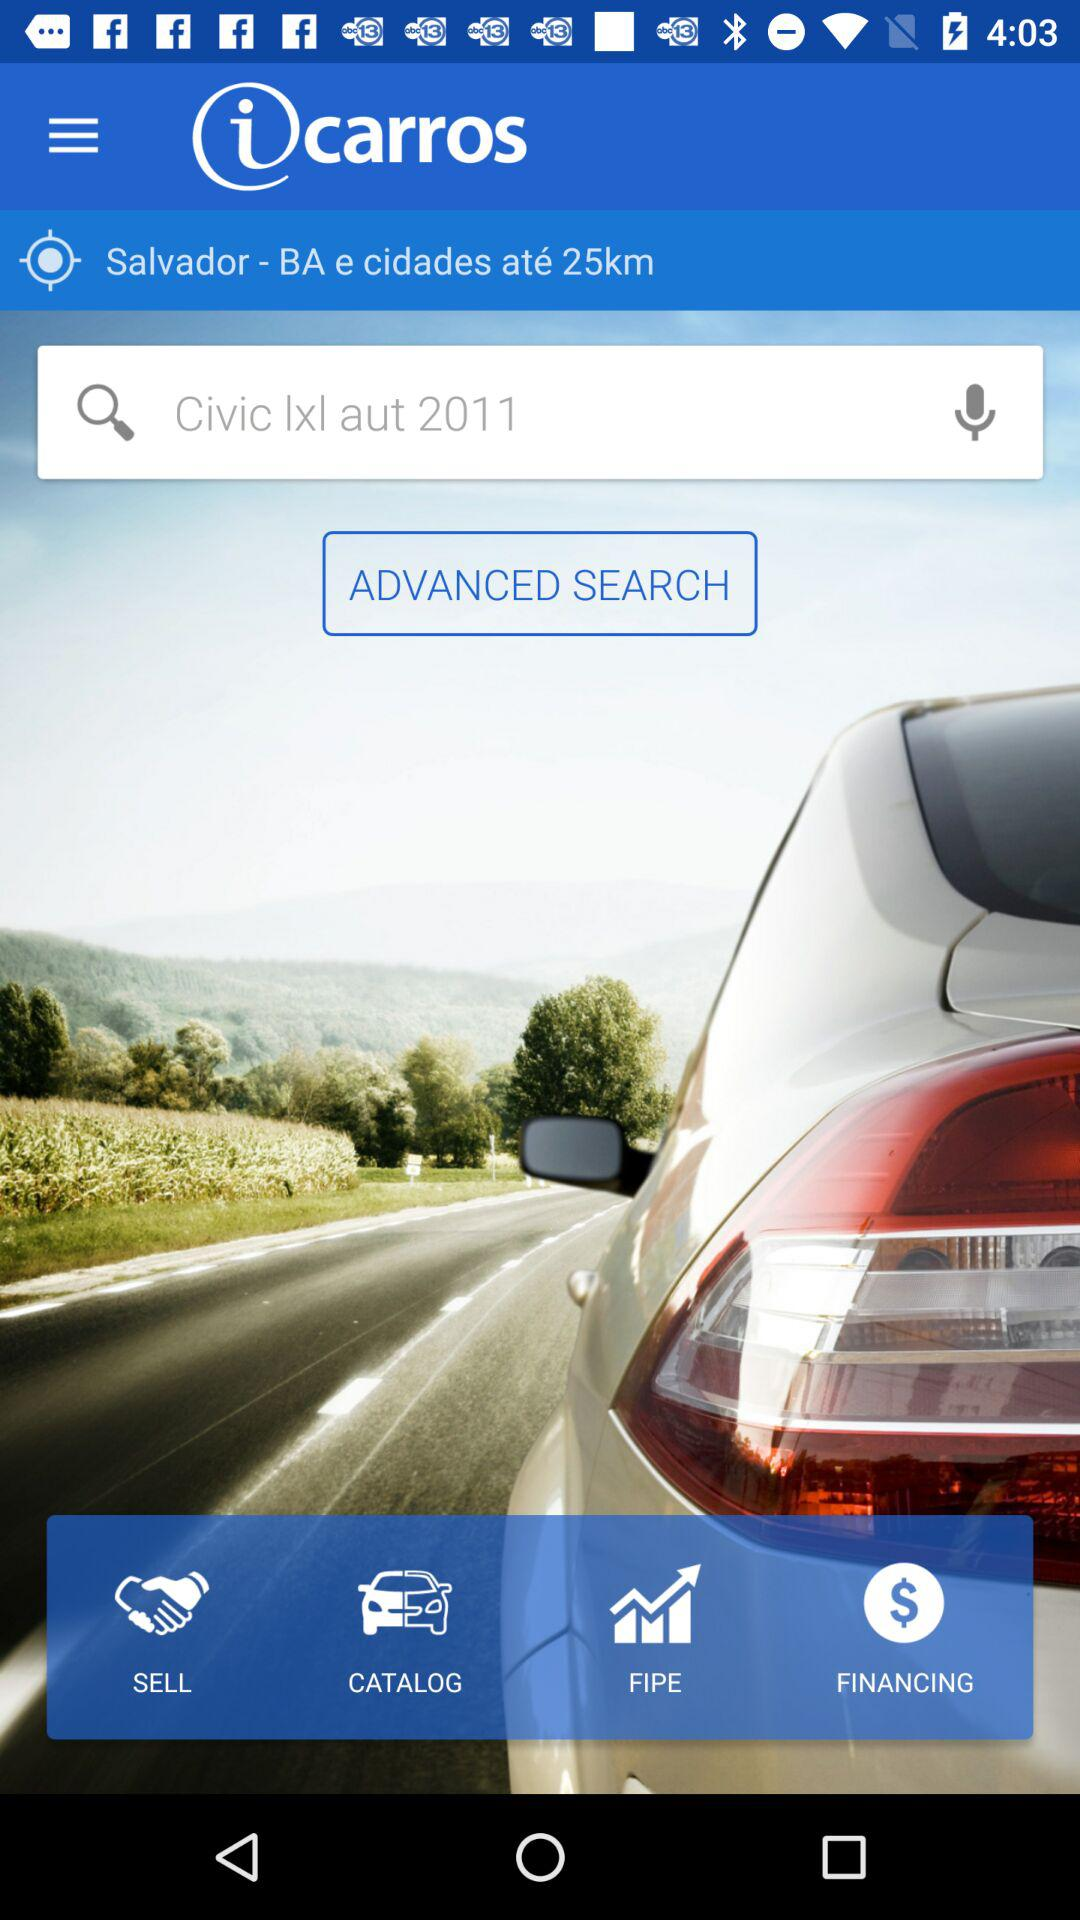What is the model of the car displayed on the screen? The model of the car displayed on the screen is "Civic lxl aut 2011". 